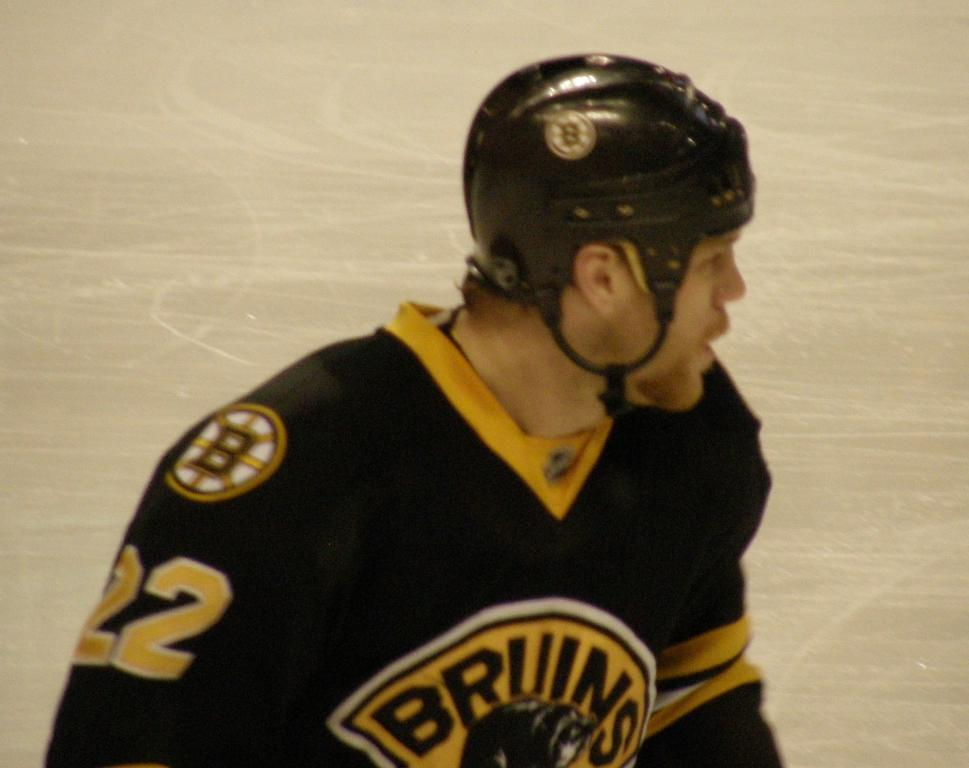What is the main subject of the image? The main subject of the image is a man. What is the man doing in the image? The man is standing in the image. What is the man wearing in the image? The man is wearing black color sports wear and a black helmet. Are there any specific details on the man's sports wear? Yes, the sports wear has some numbers on it. What type of writer is the man in the image? The image does not show the man as a writer, nor does it provide any information about his profession or hobbies. 